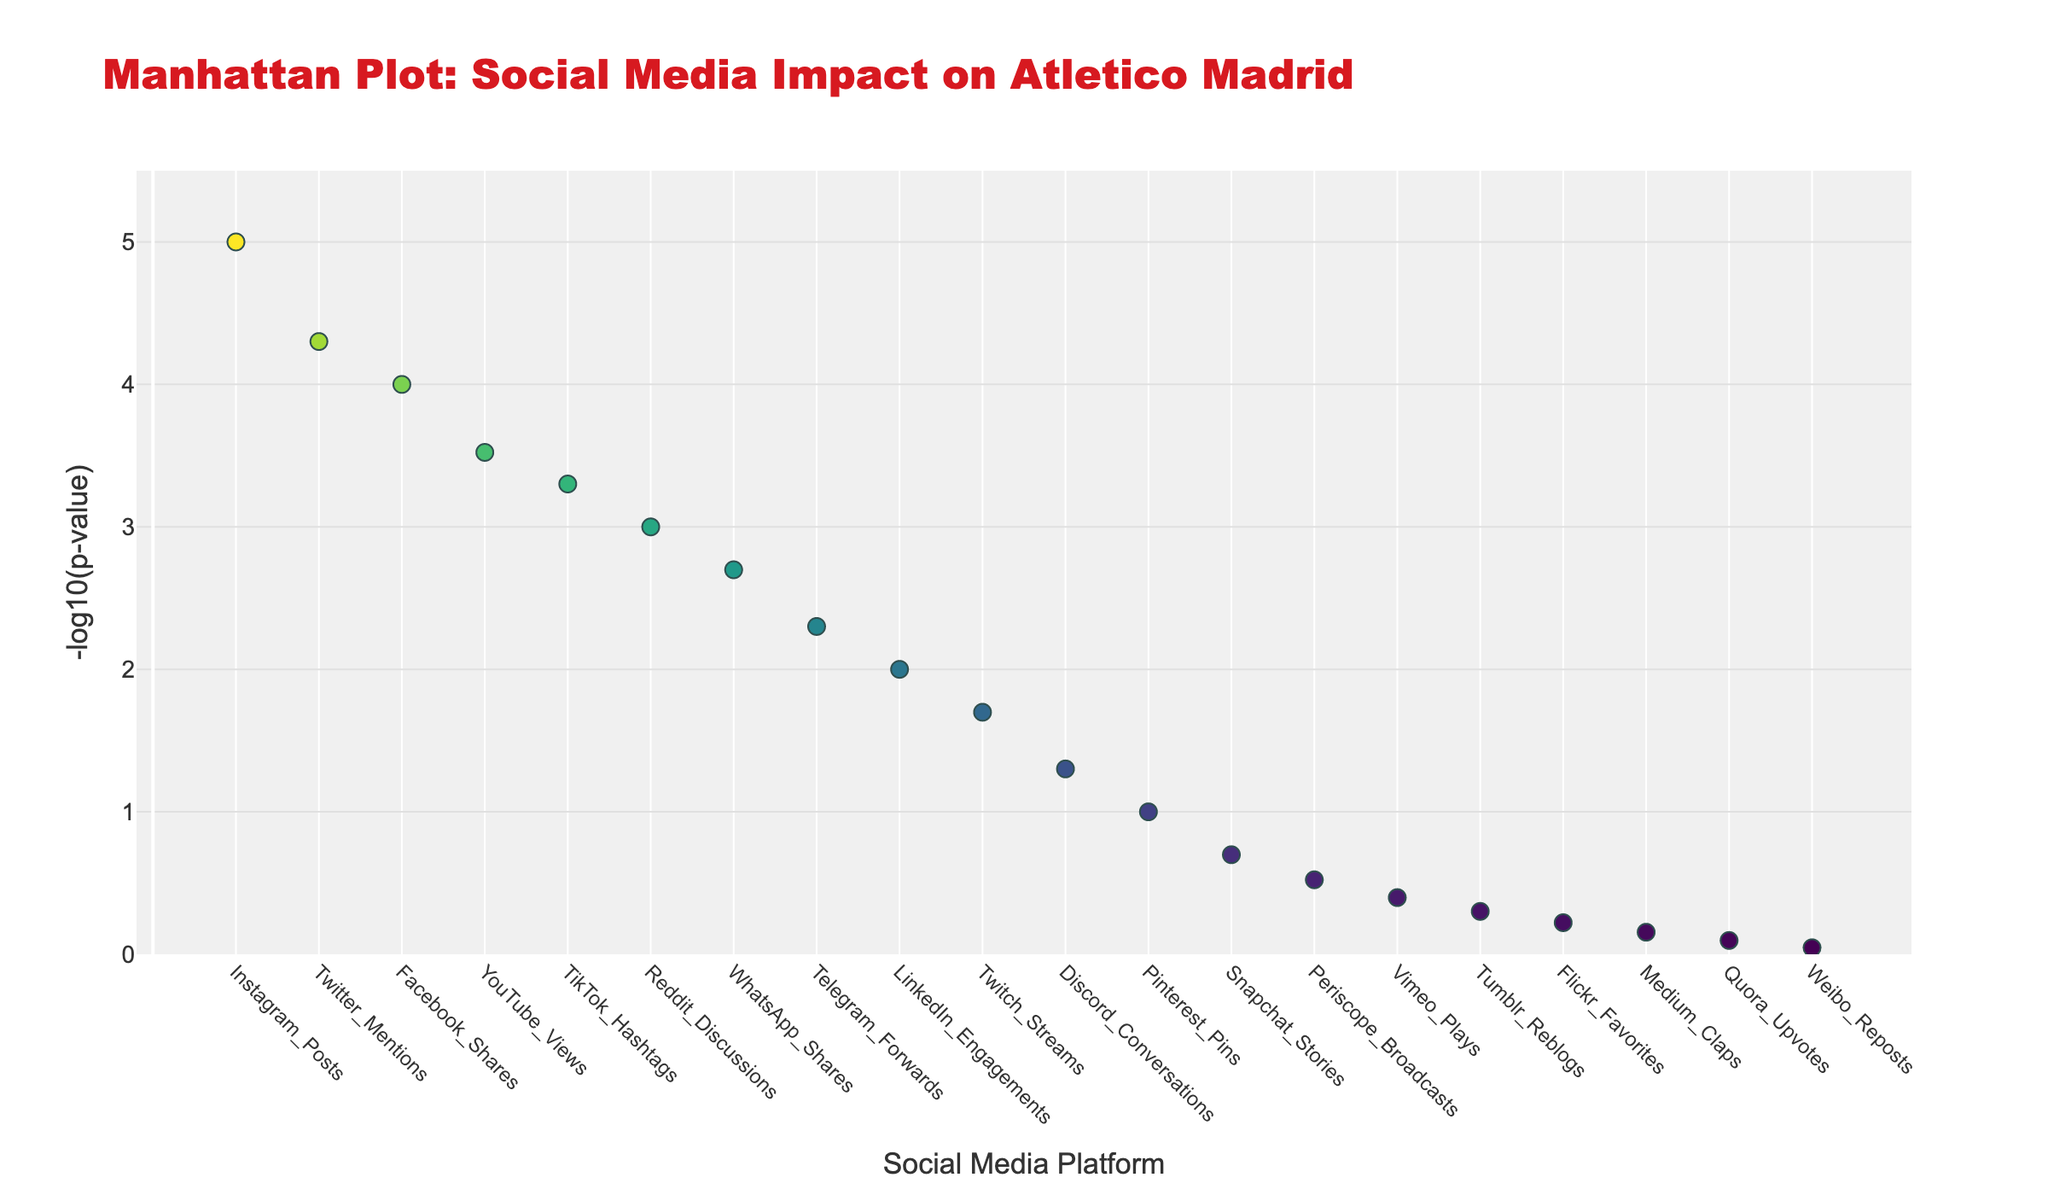What's the highest -log10(p-value) in the plot? The highest point on the plot is labeled "Instagram_Posts". Looking at the y-axis, the highest -log10(p-value) is approximately 5
Answer: 5 Which social media platform has the lowest -log10(p-value)? The lowest point on the plot is labeled "Weibo_Reposts". It has the smallest value on the y-axis, corresponding to a -log10(p-value) of approximately 0.045
Answer: Weibo_Reposts What is the title of the plot? The title is given at the top of the plot, which reads "Manhattan Plot: Social Media Impact on Atletico Madrid"
Answer: Manhattan Plot: Social Media Impact on Atletico Madrid How many social media platforms have a -log10(p-value) greater than 2? By visually inspecting the plot, it's clear that there are 7 points above the y-value of 2. These are: Instagram_Posts, Twitter_Mentions, Facebook_Shares, YouTube_Views, TikTok_Hashtags, Reddit_Discussions, and WhatsApp_Shares
Answer: 7 What are the y-axis labels representing? The y-axis is labeled "-log10(p-value)", indicating that the y-values are the negative log base 10 of the p-values
Answer: -log10(p-value) Compare the -log10(p-value) of "Twitter_Mentions" and "LinkedIn_Engagements". Which one is higher? "Twitter_Mentions" is higher than "LinkedIn_Engagements" by observation. Twitter_Mentions has a value around 4.3, while LinkedIn_Engagements has a value around 2
Answer: Twitter_Mentions Identify the social media platform with the position 7. What is its -log10(p-value)? Looking at the plot position 7, the corresponding label is "WhatsApp_Shares". Its -log10(p-value) is approximately 2.7
Answer: WhatsApp_Shares What is the color scheme used for the markers in the plot? The plot uses a "Viridis" colorscale, which ranges from purple to yellow
Answer: Viridis Is there any point with a -log10(p-value) exactly at 3? There is no point exactly at -log10(p-value) = 3; the closest points are just below or above this value
Answer: No Which two platforms have -log10(p-values) closest to each other? By observing the plot, "Vimeo_Plays" and "Tumblr_Reblogs" have very similar -log10(p-values), both near 0.4 and 0.3 respectively
Answer: Vimeo_Plays and Tumblr_Reblogs 